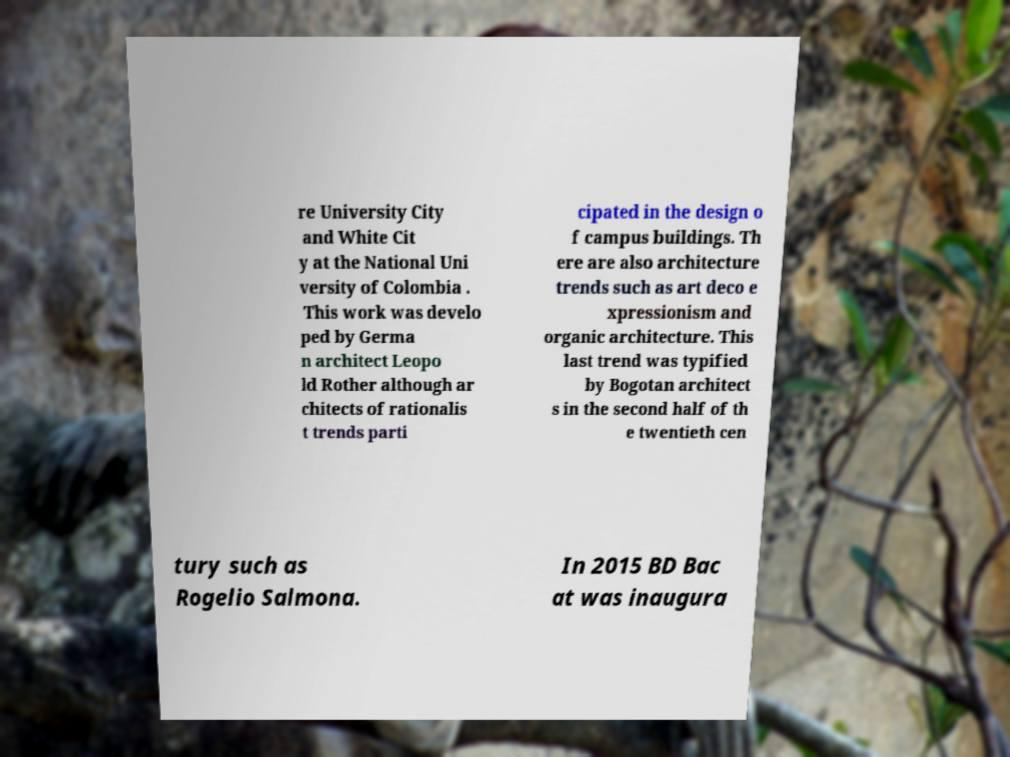Can you accurately transcribe the text from the provided image for me? re University City and White Cit y at the National Uni versity of Colombia . This work was develo ped by Germa n architect Leopo ld Rother although ar chitects of rationalis t trends parti cipated in the design o f campus buildings. Th ere are also architecture trends such as art deco e xpressionism and organic architecture. This last trend was typified by Bogotan architect s in the second half of th e twentieth cen tury such as Rogelio Salmona. In 2015 BD Bac at was inaugura 